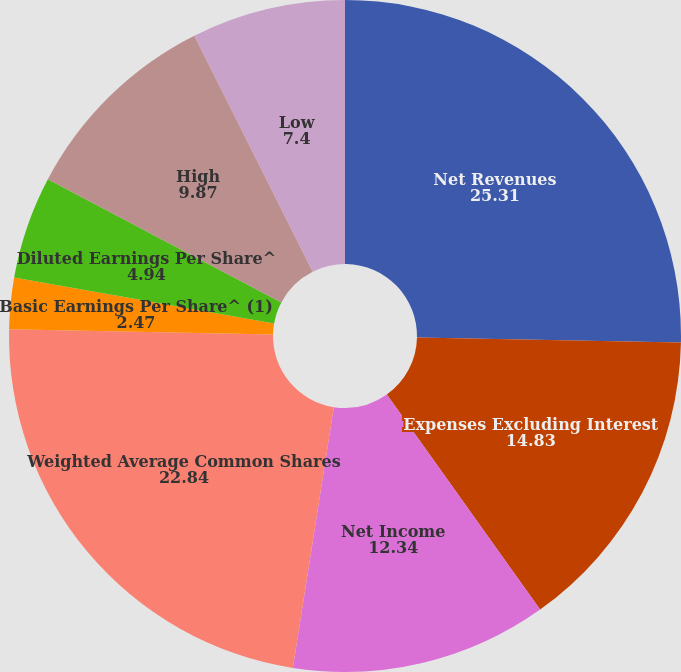Convert chart to OTSL. <chart><loc_0><loc_0><loc_500><loc_500><pie_chart><fcel>Net Revenues<fcel>Expenses Excluding Interest<fcel>Net Income<fcel>Weighted Average Common Shares<fcel>Basic Earnings Per Share^ (1)<fcel>Diluted Earnings Per Share^<fcel>Dividends Declared Per Common<fcel>High<fcel>Low<nl><fcel>25.31%<fcel>14.83%<fcel>12.34%<fcel>22.84%<fcel>2.47%<fcel>4.94%<fcel>0.0%<fcel>9.87%<fcel>7.4%<nl></chart> 